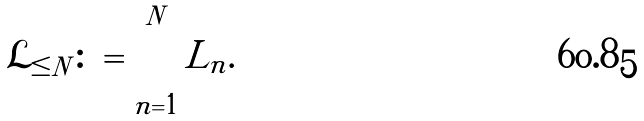Convert formula to latex. <formula><loc_0><loc_0><loc_500><loc_500>\mathcal { L } _ { \leq N } \colon = \bigcup _ { n = 1 } ^ { N } L _ { n } .</formula> 